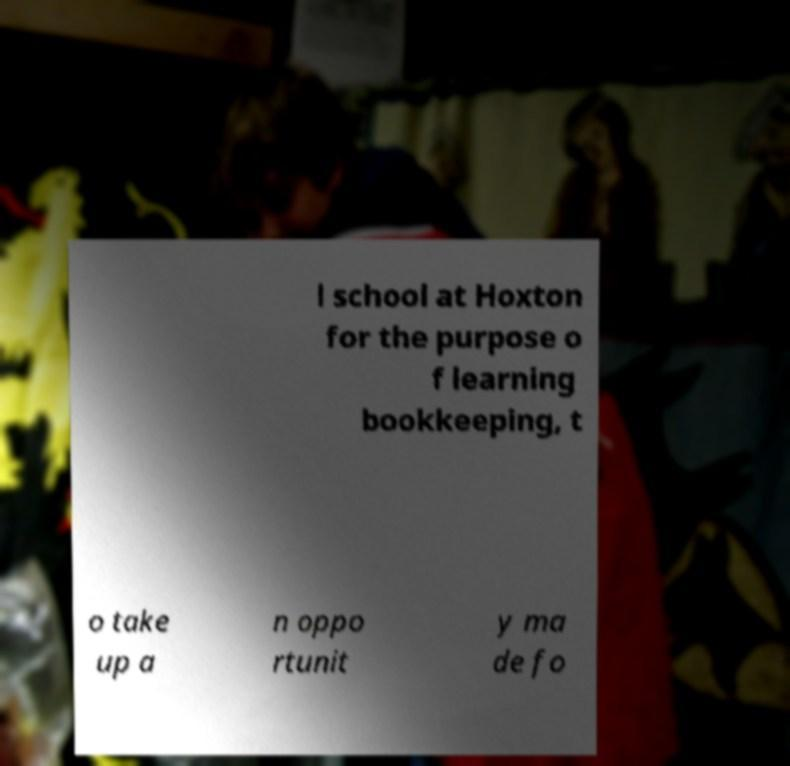Could you extract and type out the text from this image? l school at Hoxton for the purpose o f learning bookkeeping, t o take up a n oppo rtunit y ma de fo 